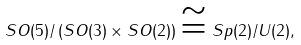Convert formula to latex. <formula><loc_0><loc_0><loc_500><loc_500>S O ( 5 ) / \left ( S O ( 3 ) \times S O ( 2 ) \right ) \cong S p ( 2 ) / U ( 2 ) ,</formula> 